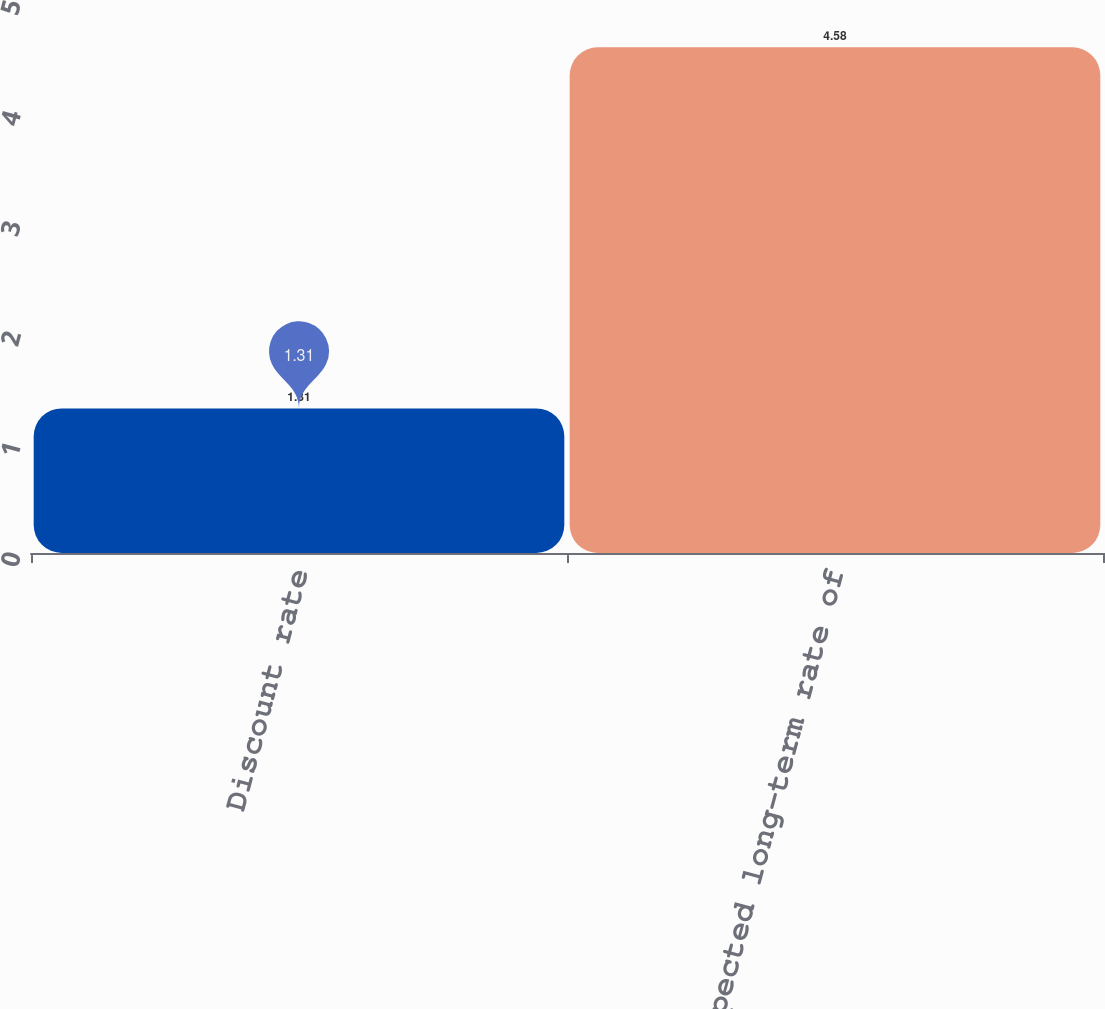<chart> <loc_0><loc_0><loc_500><loc_500><bar_chart><fcel>Discount rate<fcel>Expected long-term rate of<nl><fcel>1.31<fcel>4.58<nl></chart> 